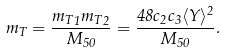Convert formula to latex. <formula><loc_0><loc_0><loc_500><loc_500>m _ { T } = \frac { { { m _ { T } } _ { 1 } } { { m _ { T } } _ { 2 } } } { M _ { 5 0 } } = \frac { 4 8 c _ { 2 } c _ { 3 } \langle Y \rangle ^ { 2 } } { M _ { 5 0 } } .</formula> 